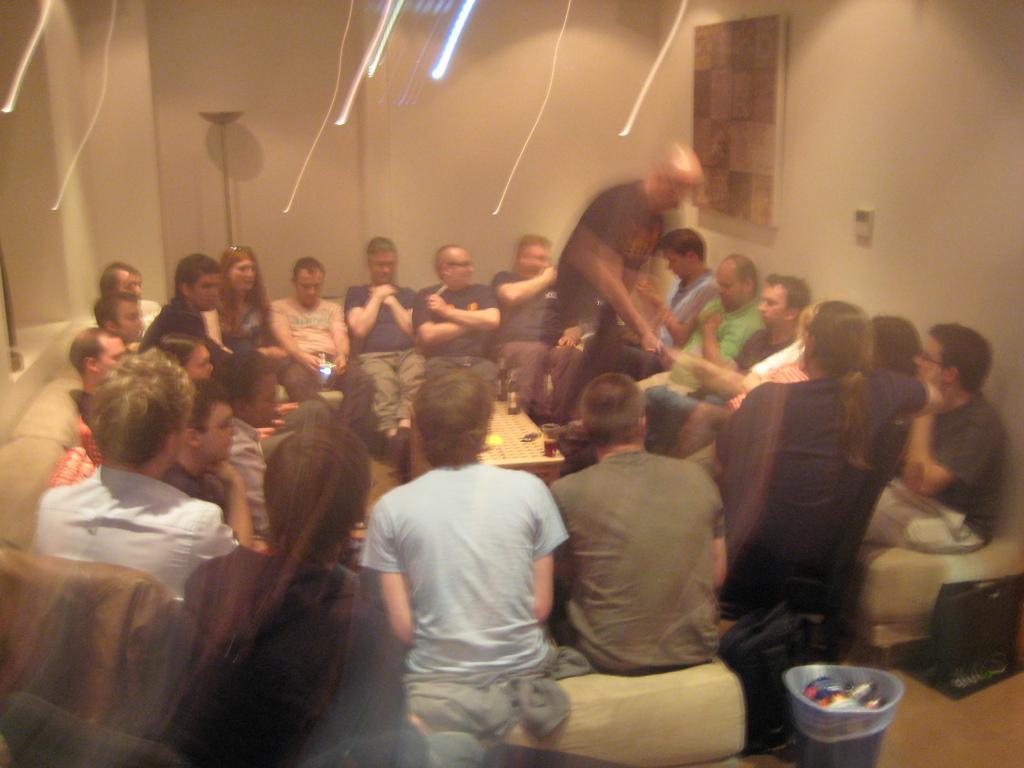How would you summarize this image in a sentence or two? This is an inside view. Here I can see few people are sitting on couches. In the middle there is a table on which I can see two glasses. Beside the table a man is standing. At the bottom of the image I can see a bucket. In the background there is a wall to which a frame is attached. 